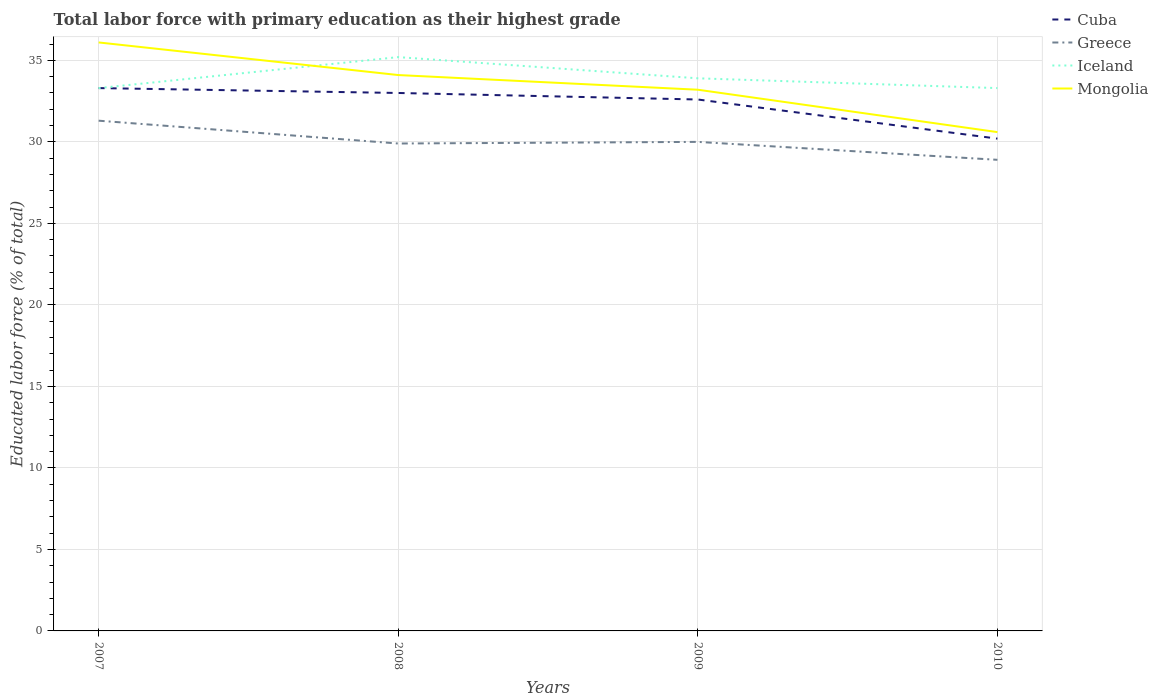Across all years, what is the maximum percentage of total labor force with primary education in Cuba?
Provide a succinct answer. 30.2. In which year was the percentage of total labor force with primary education in Greece maximum?
Keep it short and to the point. 2010. What is the total percentage of total labor force with primary education in Cuba in the graph?
Provide a succinct answer. 3.1. What is the difference between the highest and the second highest percentage of total labor force with primary education in Mongolia?
Offer a very short reply. 5.5. What is the difference between the highest and the lowest percentage of total labor force with primary education in Iceland?
Ensure brevity in your answer.  1. How many years are there in the graph?
Your answer should be compact. 4. Are the values on the major ticks of Y-axis written in scientific E-notation?
Your answer should be compact. No. Does the graph contain any zero values?
Give a very brief answer. No. How many legend labels are there?
Keep it short and to the point. 4. What is the title of the graph?
Your answer should be compact. Total labor force with primary education as their highest grade. What is the label or title of the Y-axis?
Provide a short and direct response. Educated labor force (% of total). What is the Educated labor force (% of total) in Cuba in 2007?
Your answer should be compact. 33.3. What is the Educated labor force (% of total) in Greece in 2007?
Provide a succinct answer. 31.3. What is the Educated labor force (% of total) of Iceland in 2007?
Provide a short and direct response. 33.3. What is the Educated labor force (% of total) of Mongolia in 2007?
Offer a very short reply. 36.1. What is the Educated labor force (% of total) of Cuba in 2008?
Provide a succinct answer. 33. What is the Educated labor force (% of total) in Greece in 2008?
Provide a short and direct response. 29.9. What is the Educated labor force (% of total) of Iceland in 2008?
Give a very brief answer. 35.2. What is the Educated labor force (% of total) of Mongolia in 2008?
Offer a terse response. 34.1. What is the Educated labor force (% of total) of Cuba in 2009?
Offer a terse response. 32.6. What is the Educated labor force (% of total) of Iceland in 2009?
Provide a short and direct response. 33.9. What is the Educated labor force (% of total) of Mongolia in 2009?
Give a very brief answer. 33.2. What is the Educated labor force (% of total) of Cuba in 2010?
Keep it short and to the point. 30.2. What is the Educated labor force (% of total) in Greece in 2010?
Ensure brevity in your answer.  28.9. What is the Educated labor force (% of total) of Iceland in 2010?
Ensure brevity in your answer.  33.3. What is the Educated labor force (% of total) in Mongolia in 2010?
Your response must be concise. 30.6. Across all years, what is the maximum Educated labor force (% of total) of Cuba?
Give a very brief answer. 33.3. Across all years, what is the maximum Educated labor force (% of total) in Greece?
Offer a terse response. 31.3. Across all years, what is the maximum Educated labor force (% of total) in Iceland?
Provide a succinct answer. 35.2. Across all years, what is the maximum Educated labor force (% of total) in Mongolia?
Keep it short and to the point. 36.1. Across all years, what is the minimum Educated labor force (% of total) in Cuba?
Your answer should be compact. 30.2. Across all years, what is the minimum Educated labor force (% of total) of Greece?
Give a very brief answer. 28.9. Across all years, what is the minimum Educated labor force (% of total) in Iceland?
Ensure brevity in your answer.  33.3. Across all years, what is the minimum Educated labor force (% of total) in Mongolia?
Provide a succinct answer. 30.6. What is the total Educated labor force (% of total) in Cuba in the graph?
Provide a succinct answer. 129.1. What is the total Educated labor force (% of total) of Greece in the graph?
Give a very brief answer. 120.1. What is the total Educated labor force (% of total) in Iceland in the graph?
Provide a succinct answer. 135.7. What is the total Educated labor force (% of total) of Mongolia in the graph?
Keep it short and to the point. 134. What is the difference between the Educated labor force (% of total) in Greece in 2007 and that in 2008?
Ensure brevity in your answer.  1.4. What is the difference between the Educated labor force (% of total) of Mongolia in 2007 and that in 2009?
Give a very brief answer. 2.9. What is the difference between the Educated labor force (% of total) in Cuba in 2007 and that in 2010?
Provide a succinct answer. 3.1. What is the difference between the Educated labor force (% of total) in Mongolia in 2007 and that in 2010?
Give a very brief answer. 5.5. What is the difference between the Educated labor force (% of total) in Cuba in 2008 and that in 2009?
Your answer should be very brief. 0.4. What is the difference between the Educated labor force (% of total) of Iceland in 2008 and that in 2009?
Give a very brief answer. 1.3. What is the difference between the Educated labor force (% of total) in Mongolia in 2008 and that in 2009?
Your answer should be compact. 0.9. What is the difference between the Educated labor force (% of total) of Greece in 2008 and that in 2010?
Provide a succinct answer. 1. What is the difference between the Educated labor force (% of total) in Iceland in 2009 and that in 2010?
Your response must be concise. 0.6. What is the difference between the Educated labor force (% of total) in Mongolia in 2009 and that in 2010?
Your answer should be very brief. 2.6. What is the difference between the Educated labor force (% of total) of Cuba in 2007 and the Educated labor force (% of total) of Greece in 2008?
Give a very brief answer. 3.4. What is the difference between the Educated labor force (% of total) in Cuba in 2007 and the Educated labor force (% of total) in Iceland in 2008?
Ensure brevity in your answer.  -1.9. What is the difference between the Educated labor force (% of total) in Greece in 2007 and the Educated labor force (% of total) in Iceland in 2008?
Make the answer very short. -3.9. What is the difference between the Educated labor force (% of total) of Greece in 2007 and the Educated labor force (% of total) of Mongolia in 2008?
Your answer should be compact. -2.8. What is the difference between the Educated labor force (% of total) of Iceland in 2007 and the Educated labor force (% of total) of Mongolia in 2008?
Your answer should be compact. -0.8. What is the difference between the Educated labor force (% of total) of Cuba in 2007 and the Educated labor force (% of total) of Mongolia in 2009?
Provide a succinct answer. 0.1. What is the difference between the Educated labor force (% of total) of Greece in 2007 and the Educated labor force (% of total) of Iceland in 2009?
Keep it short and to the point. -2.6. What is the difference between the Educated labor force (% of total) of Cuba in 2007 and the Educated labor force (% of total) of Greece in 2010?
Provide a short and direct response. 4.4. What is the difference between the Educated labor force (% of total) in Cuba in 2007 and the Educated labor force (% of total) in Mongolia in 2010?
Offer a terse response. 2.7. What is the difference between the Educated labor force (% of total) of Greece in 2007 and the Educated labor force (% of total) of Iceland in 2010?
Your answer should be compact. -2. What is the difference between the Educated labor force (% of total) of Greece in 2007 and the Educated labor force (% of total) of Mongolia in 2010?
Offer a terse response. 0.7. What is the difference between the Educated labor force (% of total) of Cuba in 2008 and the Educated labor force (% of total) of Mongolia in 2009?
Make the answer very short. -0.2. What is the difference between the Educated labor force (% of total) in Greece in 2008 and the Educated labor force (% of total) in Mongolia in 2009?
Your answer should be compact. -3.3. What is the difference between the Educated labor force (% of total) in Cuba in 2008 and the Educated labor force (% of total) in Iceland in 2010?
Give a very brief answer. -0.3. What is the difference between the Educated labor force (% of total) of Greece in 2008 and the Educated labor force (% of total) of Iceland in 2010?
Give a very brief answer. -3.4. What is the difference between the Educated labor force (% of total) of Cuba in 2009 and the Educated labor force (% of total) of Greece in 2010?
Provide a short and direct response. 3.7. What is the difference between the Educated labor force (% of total) in Greece in 2009 and the Educated labor force (% of total) in Mongolia in 2010?
Give a very brief answer. -0.6. What is the average Educated labor force (% of total) in Cuba per year?
Provide a succinct answer. 32.27. What is the average Educated labor force (% of total) in Greece per year?
Keep it short and to the point. 30.02. What is the average Educated labor force (% of total) of Iceland per year?
Your response must be concise. 33.92. What is the average Educated labor force (% of total) of Mongolia per year?
Your answer should be very brief. 33.5. In the year 2007, what is the difference between the Educated labor force (% of total) in Iceland and Educated labor force (% of total) in Mongolia?
Provide a succinct answer. -2.8. In the year 2008, what is the difference between the Educated labor force (% of total) of Cuba and Educated labor force (% of total) of Greece?
Offer a very short reply. 3.1. In the year 2008, what is the difference between the Educated labor force (% of total) in Greece and Educated labor force (% of total) in Iceland?
Your response must be concise. -5.3. In the year 2008, what is the difference between the Educated labor force (% of total) of Greece and Educated labor force (% of total) of Mongolia?
Provide a succinct answer. -4.2. In the year 2008, what is the difference between the Educated labor force (% of total) of Iceland and Educated labor force (% of total) of Mongolia?
Your answer should be compact. 1.1. In the year 2009, what is the difference between the Educated labor force (% of total) of Cuba and Educated labor force (% of total) of Mongolia?
Your answer should be very brief. -0.6. In the year 2009, what is the difference between the Educated labor force (% of total) of Greece and Educated labor force (% of total) of Iceland?
Keep it short and to the point. -3.9. In the year 2009, what is the difference between the Educated labor force (% of total) in Greece and Educated labor force (% of total) in Mongolia?
Provide a short and direct response. -3.2. In the year 2009, what is the difference between the Educated labor force (% of total) in Iceland and Educated labor force (% of total) in Mongolia?
Your answer should be very brief. 0.7. In the year 2010, what is the difference between the Educated labor force (% of total) of Cuba and Educated labor force (% of total) of Greece?
Provide a succinct answer. 1.3. In the year 2010, what is the difference between the Educated labor force (% of total) of Cuba and Educated labor force (% of total) of Iceland?
Your answer should be very brief. -3.1. In the year 2010, what is the difference between the Educated labor force (% of total) in Cuba and Educated labor force (% of total) in Mongolia?
Provide a succinct answer. -0.4. What is the ratio of the Educated labor force (% of total) in Cuba in 2007 to that in 2008?
Keep it short and to the point. 1.01. What is the ratio of the Educated labor force (% of total) in Greece in 2007 to that in 2008?
Offer a terse response. 1.05. What is the ratio of the Educated labor force (% of total) of Iceland in 2007 to that in 2008?
Keep it short and to the point. 0.95. What is the ratio of the Educated labor force (% of total) of Mongolia in 2007 to that in 2008?
Your response must be concise. 1.06. What is the ratio of the Educated labor force (% of total) in Cuba in 2007 to that in 2009?
Provide a succinct answer. 1.02. What is the ratio of the Educated labor force (% of total) in Greece in 2007 to that in 2009?
Provide a short and direct response. 1.04. What is the ratio of the Educated labor force (% of total) in Iceland in 2007 to that in 2009?
Your answer should be compact. 0.98. What is the ratio of the Educated labor force (% of total) in Mongolia in 2007 to that in 2009?
Keep it short and to the point. 1.09. What is the ratio of the Educated labor force (% of total) in Cuba in 2007 to that in 2010?
Your answer should be compact. 1.1. What is the ratio of the Educated labor force (% of total) of Greece in 2007 to that in 2010?
Provide a short and direct response. 1.08. What is the ratio of the Educated labor force (% of total) in Iceland in 2007 to that in 2010?
Provide a short and direct response. 1. What is the ratio of the Educated labor force (% of total) in Mongolia in 2007 to that in 2010?
Offer a terse response. 1.18. What is the ratio of the Educated labor force (% of total) in Cuba in 2008 to that in 2009?
Your answer should be compact. 1.01. What is the ratio of the Educated labor force (% of total) in Greece in 2008 to that in 2009?
Your answer should be compact. 1. What is the ratio of the Educated labor force (% of total) in Iceland in 2008 to that in 2009?
Your answer should be compact. 1.04. What is the ratio of the Educated labor force (% of total) of Mongolia in 2008 to that in 2009?
Give a very brief answer. 1.03. What is the ratio of the Educated labor force (% of total) of Cuba in 2008 to that in 2010?
Make the answer very short. 1.09. What is the ratio of the Educated labor force (% of total) in Greece in 2008 to that in 2010?
Provide a succinct answer. 1.03. What is the ratio of the Educated labor force (% of total) of Iceland in 2008 to that in 2010?
Offer a very short reply. 1.06. What is the ratio of the Educated labor force (% of total) of Mongolia in 2008 to that in 2010?
Keep it short and to the point. 1.11. What is the ratio of the Educated labor force (% of total) in Cuba in 2009 to that in 2010?
Give a very brief answer. 1.08. What is the ratio of the Educated labor force (% of total) in Greece in 2009 to that in 2010?
Give a very brief answer. 1.04. What is the ratio of the Educated labor force (% of total) in Mongolia in 2009 to that in 2010?
Offer a terse response. 1.08. What is the difference between the highest and the second highest Educated labor force (% of total) in Cuba?
Your answer should be compact. 0.3. What is the difference between the highest and the second highest Educated labor force (% of total) in Iceland?
Your answer should be very brief. 1.3. What is the difference between the highest and the second highest Educated labor force (% of total) of Mongolia?
Your answer should be compact. 2. What is the difference between the highest and the lowest Educated labor force (% of total) of Cuba?
Ensure brevity in your answer.  3.1. What is the difference between the highest and the lowest Educated labor force (% of total) of Iceland?
Provide a short and direct response. 1.9. What is the difference between the highest and the lowest Educated labor force (% of total) of Mongolia?
Your response must be concise. 5.5. 